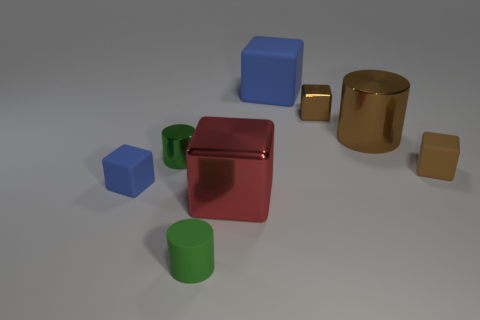There is a big matte block; is its color the same as the metallic cube on the right side of the large red shiny cube?
Your response must be concise. No. Is there any other thing that is made of the same material as the big red thing?
Give a very brief answer. Yes. What shape is the large rubber object?
Offer a terse response. Cube. There is a cylinder that is in front of the blue object that is in front of the big brown metallic object; what size is it?
Your answer should be very brief. Small. Is the number of big red cubes right of the big red metallic block the same as the number of green things that are right of the tiny green rubber cylinder?
Give a very brief answer. Yes. What material is the large thing that is both behind the green shiny thing and in front of the large matte object?
Your response must be concise. Metal. Do the brown cylinder and the blue block that is behind the small green metallic object have the same size?
Ensure brevity in your answer.  Yes. How many other things are there of the same color as the big shiny cylinder?
Give a very brief answer. 2. Is the number of large blue rubber blocks in front of the green metallic cylinder greater than the number of big metal cylinders?
Provide a short and direct response. No. The big object in front of the small green thing behind the small green rubber cylinder left of the large blue thing is what color?
Offer a very short reply. Red. 